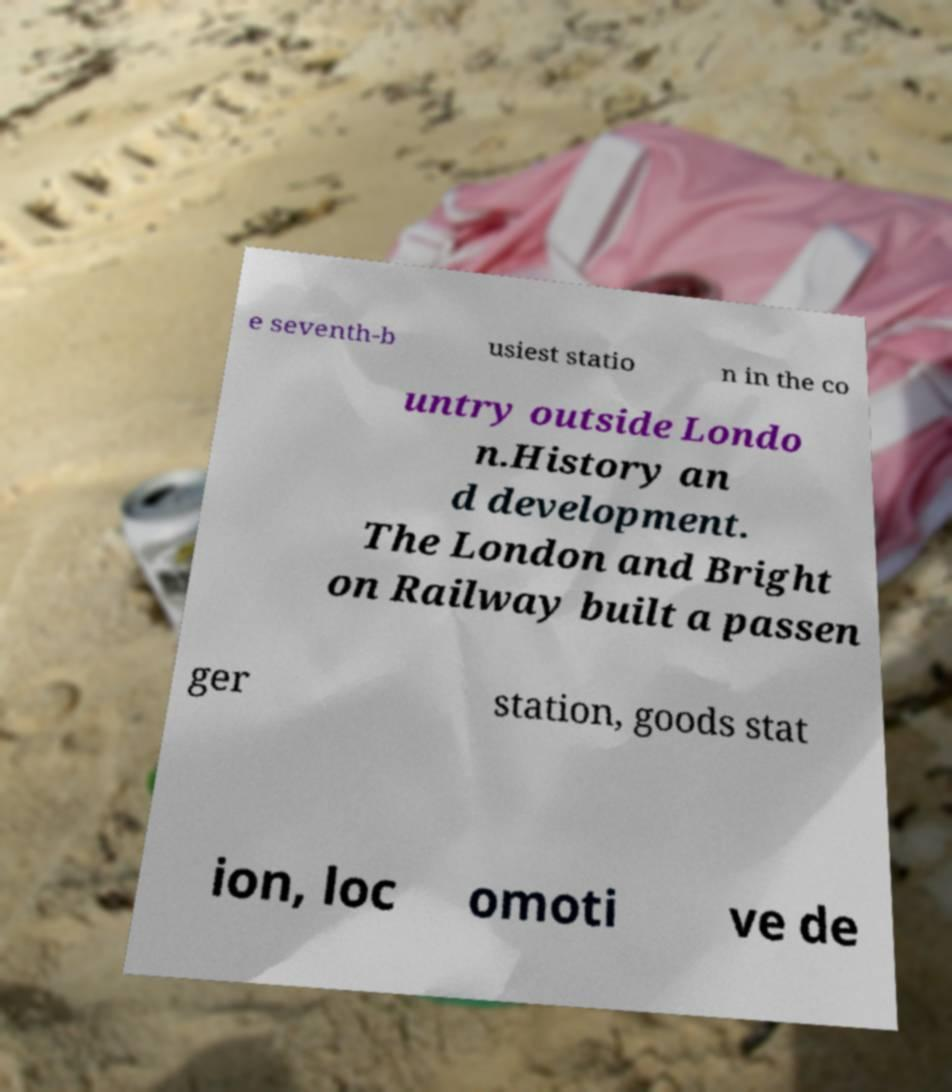What messages or text are displayed in this image? I need them in a readable, typed format. e seventh-b usiest statio n in the co untry outside Londo n.History an d development. The London and Bright on Railway built a passen ger station, goods stat ion, loc omoti ve de 